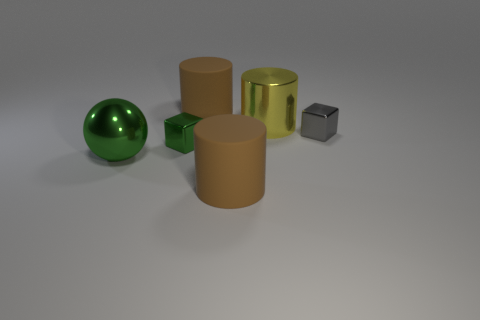Subtract 1 cylinders. How many cylinders are left? 2 Subtract all big brown matte cylinders. How many cylinders are left? 1 Add 3 small rubber cylinders. How many objects exist? 9 Subtract all spheres. How many objects are left? 5 Subtract all gray metal cubes. Subtract all green metallic things. How many objects are left? 3 Add 2 small gray cubes. How many small gray cubes are left? 3 Add 1 tiny objects. How many tiny objects exist? 3 Subtract 0 purple balls. How many objects are left? 6 